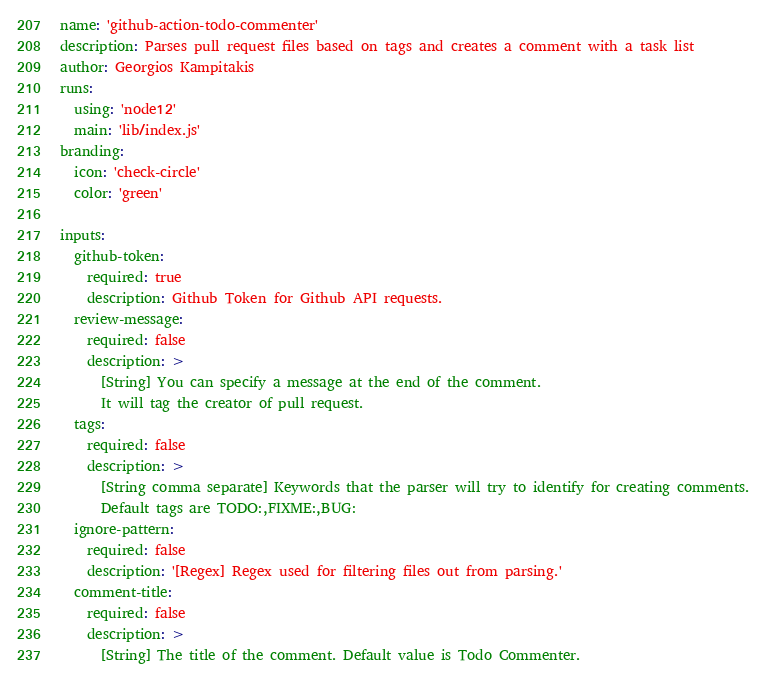Convert code to text. <code><loc_0><loc_0><loc_500><loc_500><_YAML_>name: 'github-action-todo-commenter'
description: Parses pull request files based on tags and creates a comment with a task list
author: Georgios Kampitakis
runs:
  using: 'node12'
  main: 'lib/index.js'
branding:
  icon: 'check-circle'
  color: 'green'

inputs:
  github-token:
    required: true
    description: Github Token for Github API requests.
  review-message:
    required: false
    description: >
      [String] You can specify a message at the end of the comment.
      It will tag the creator of pull request.
  tags:
    required: false
    description: >
      [String comma separate] Keywords that the parser will try to identify for creating comments.
      Default tags are TODO:,FIXME:,BUG:
  ignore-pattern:
    required: false
    description: '[Regex] Regex used for filtering files out from parsing.'
  comment-title:
    required: false
    description: >
      [String] The title of the comment. Default value is Todo Commenter.</code> 